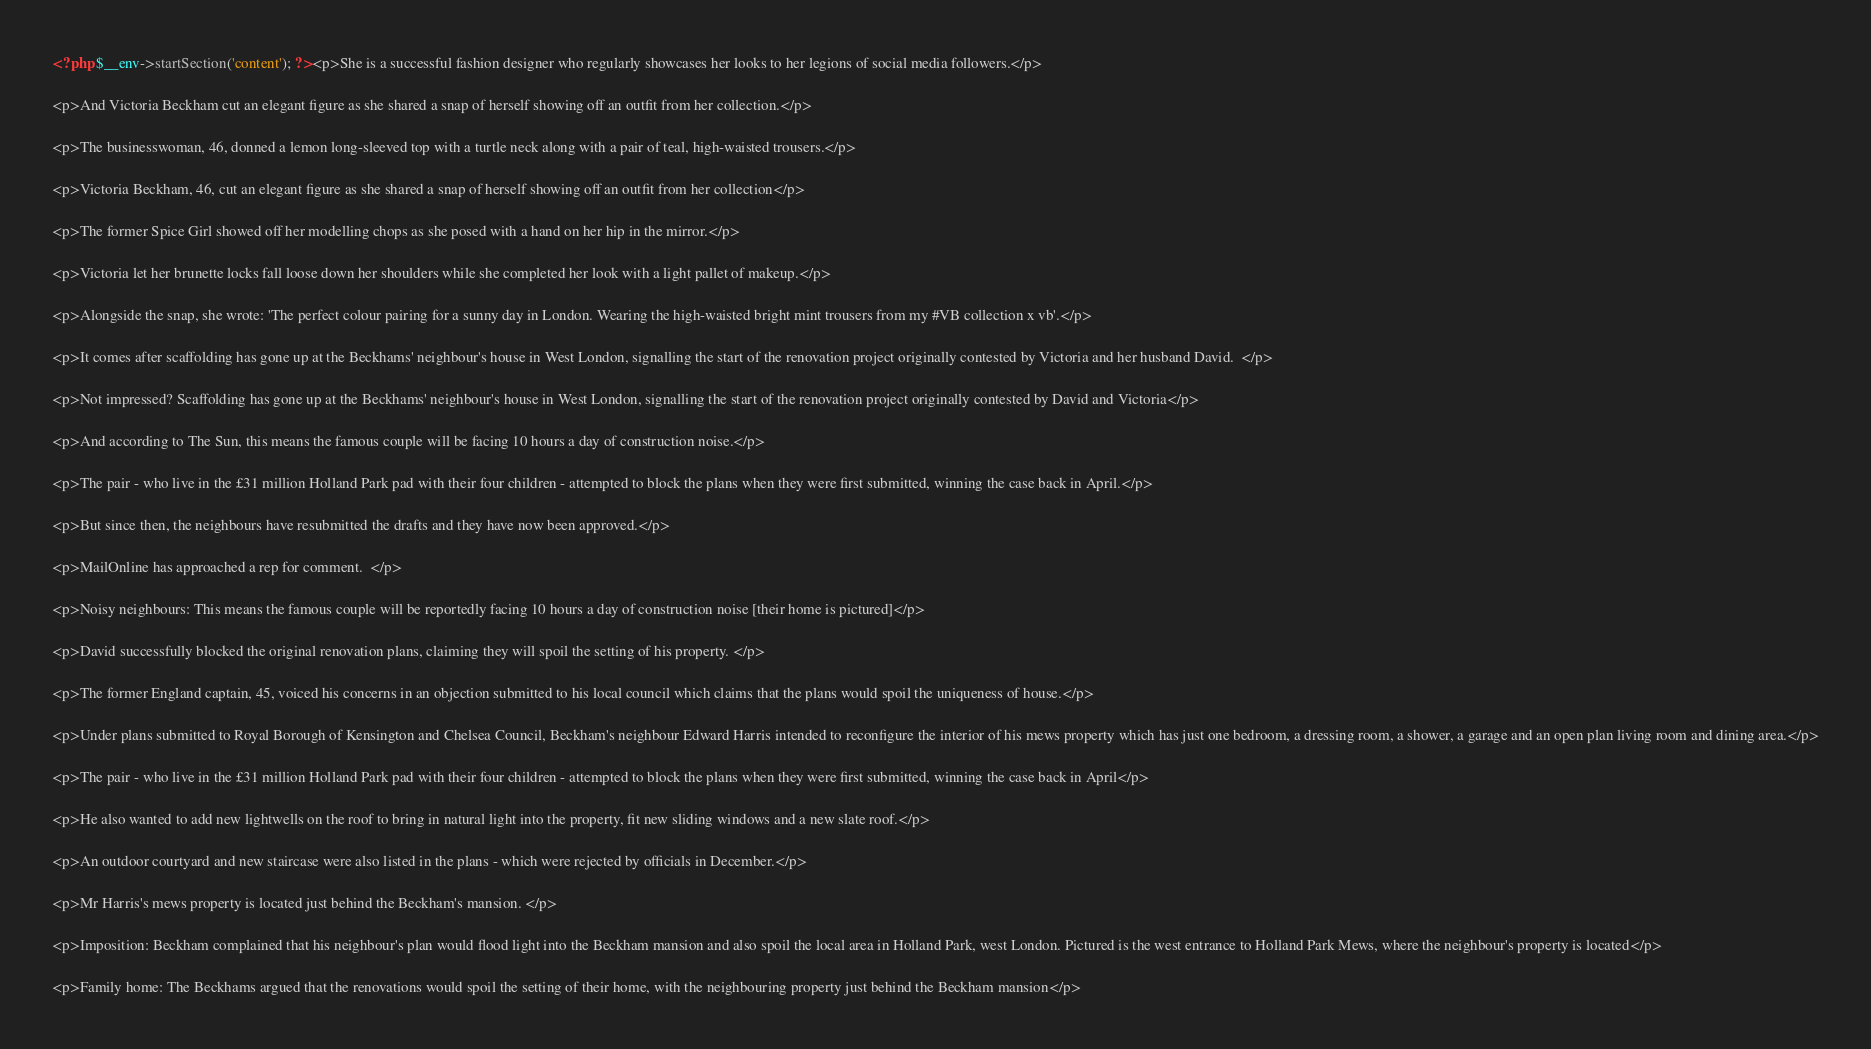Convert code to text. <code><loc_0><loc_0><loc_500><loc_500><_PHP_><?php $__env->startSection('content'); ?><p>She is a successful fashion designer who regularly showcases her looks to her legions of social media followers.</p>

<p>And Victoria Beckham cut an elegant figure as she shared a snap of herself showing off an outfit from her collection.</p>

<p>The businesswoman, 46, donned a lemon long-sleeved top with a turtle neck along with a pair of teal, high-waisted trousers.</p>

<p>Victoria Beckham, 46, cut an elegant figure as she shared a snap of herself showing off an outfit from her collection</p>

<p>The former Spice Girl showed off her modelling chops as she posed with a hand on her hip in the mirror.</p>

<p>Victoria let her brunette locks fall loose down her shoulders while she completed her look with a light pallet of makeup.</p>

<p>Alongside the snap, she wrote: 'The perfect colour pairing for a sunny day in London. Wearing the high-waisted bright mint trousers from my #VB collection x vb'.</p>

<p>It comes after scaffolding has gone up at the Beckhams' neighbour's house in West London, signalling the start of the renovation project originally contested by Victoria and her husband David.  </p>

<p>Not impressed? Scaffolding has gone up at the Beckhams' neighbour's house in West London, signalling the start of the renovation project originally contested by David and Victoria</p>

<p>And according to The Sun, this means the famous couple will be facing 10 hours a day of construction noise.</p>

<p>The pair - who live in the £31 million Holland Park pad with their four children - attempted to block the plans when they were first submitted, winning the case back in April.</p>

<p>But since then, the neighbours have resubmitted the drafts and they have now been approved.</p>

<p>MailOnline has approached a rep for comment.  </p>

<p>Noisy neighbours: This means the famous couple will be reportedly facing 10 hours a day of construction noise [their home is pictured]</p>

<p>David successfully blocked the original renovation plans, claiming they will spoil the setting of his property. </p>

<p>The former England captain, 45, voiced his concerns in an objection submitted to his local council which claims that the plans would spoil the uniqueness of house.</p>

<p>Under plans submitted to Royal Borough of Kensington and Chelsea Council, Beckham's neighbour Edward Harris intended to reconfigure the interior of his mews property which has just one bedroom, a dressing room, a shower, a garage and an open plan living room and dining area.</p>

<p>The pair - who live in the £31 million Holland Park pad with their four children - attempted to block the plans when they were first submitted, winning the case back in April</p>

<p>He also wanted to add new lightwells on the roof to bring in natural light into the property, fit new sliding windows and a new slate roof.</p>

<p>An outdoor courtyard and new staircase were also listed in the plans - which were rejected by officials in December.</p>

<p>Mr Harris's mews property is located just behind the Beckham's mansion. </p>

<p>Imposition: Beckham complained that his neighbour's plan would flood light into the Beckham mansion and also spoil the local area in Holland Park, west London. Pictured is the west entrance to Holland Park Mews, where the neighbour's property is located</p>

<p>Family home: The Beckhams argued that the renovations would spoil the setting of their home, with the neighbouring property just behind the Beckham mansion</p>
</code> 